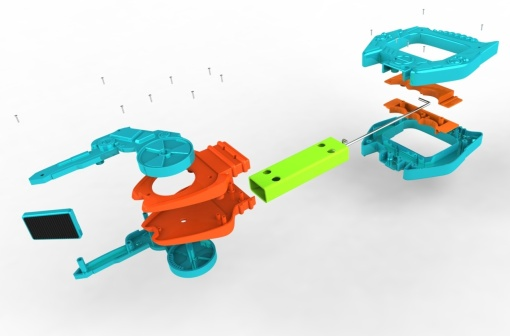Imagine if each component of the car had a personality. Describe their interactions. Sure, let's imagine each part of the toy car had a personality. The sleek orange body, being the centerpiece, could be seen as the confident leader, determined and focused on bringing everything together. The green wheels, with their fun and intricate design, might be the enthusiastic supporters, ready to roll into action at any moment. The small blue screws could be the diligent helpers, tirelessly ensuring that each part remains connected and secure. Together, they interact like a well-coordinated team, each playing its crucial role in achieving the ultimate goal of creating a fully assembled, vibrant toy car. 